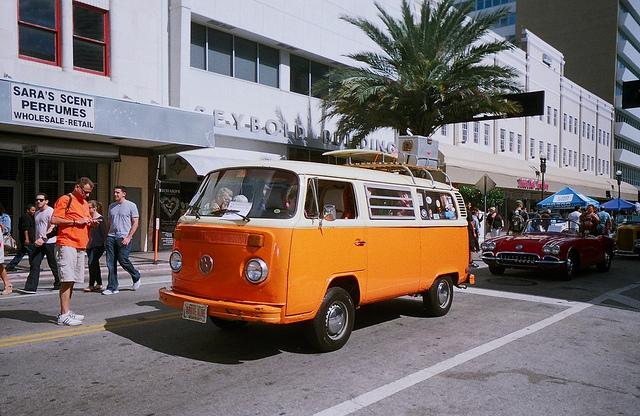What does the retail store sells?
Be succinct. Perfumes. Which brand is this vehicle?
Keep it brief. Vw. Is the man in the orange shirt looking down?
Answer briefly. Yes. Is this a tourist bus?
Quick response, please. No. 